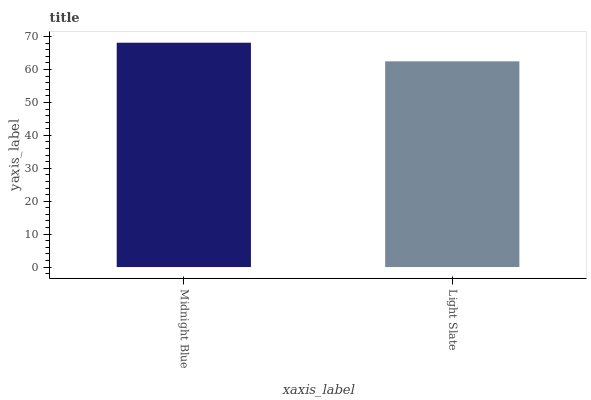Is Light Slate the minimum?
Answer yes or no. Yes. Is Midnight Blue the maximum?
Answer yes or no. Yes. Is Light Slate the maximum?
Answer yes or no. No. Is Midnight Blue greater than Light Slate?
Answer yes or no. Yes. Is Light Slate less than Midnight Blue?
Answer yes or no. Yes. Is Light Slate greater than Midnight Blue?
Answer yes or no. No. Is Midnight Blue less than Light Slate?
Answer yes or no. No. Is Midnight Blue the high median?
Answer yes or no. Yes. Is Light Slate the low median?
Answer yes or no. Yes. Is Light Slate the high median?
Answer yes or no. No. Is Midnight Blue the low median?
Answer yes or no. No. 